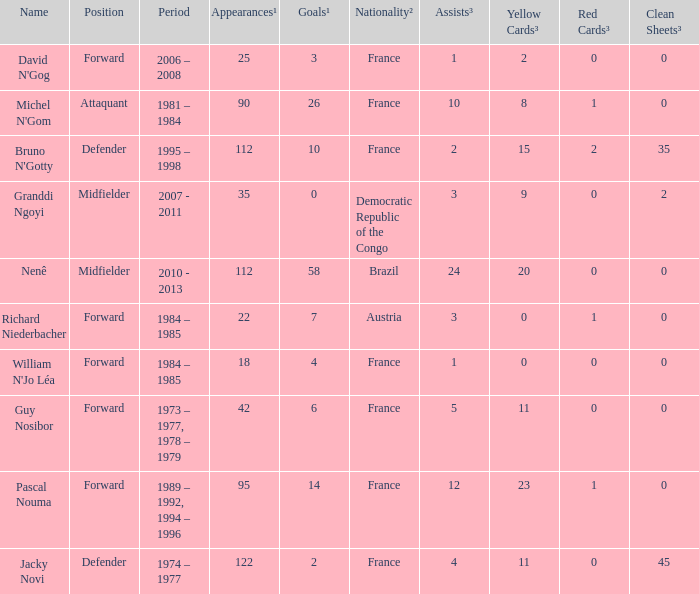How many players are from the country of Brazil? 1.0. 